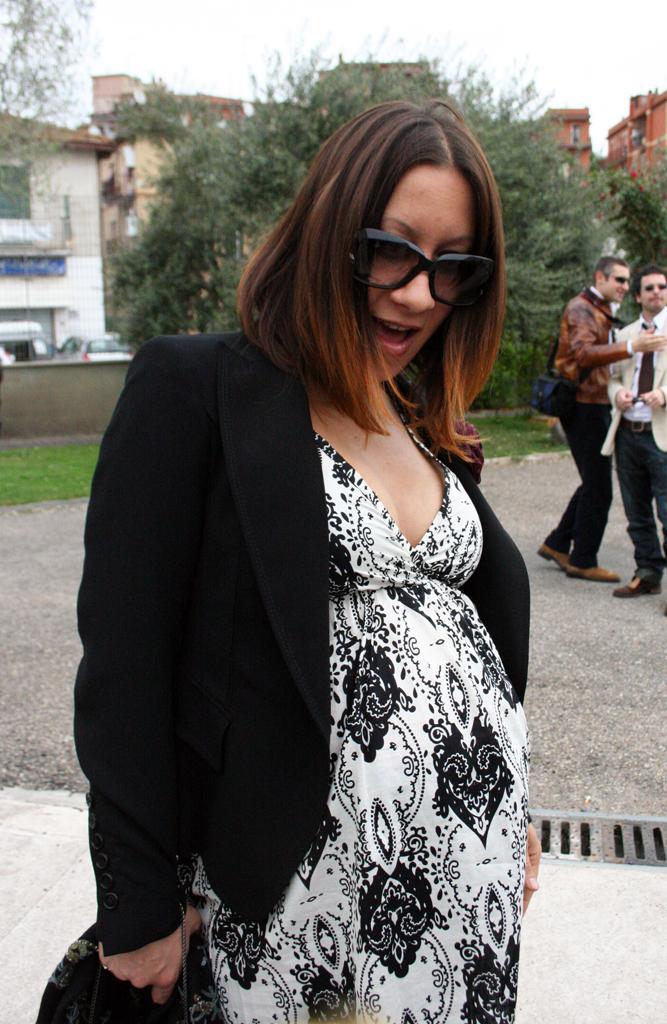How would you summarize this image in a sentence or two? In this image I can see a woman wearing white and black colored dress is stunning. In the background I can see few persons standing, few trees which are green in color, few vehicles, few buildings and the sky. 